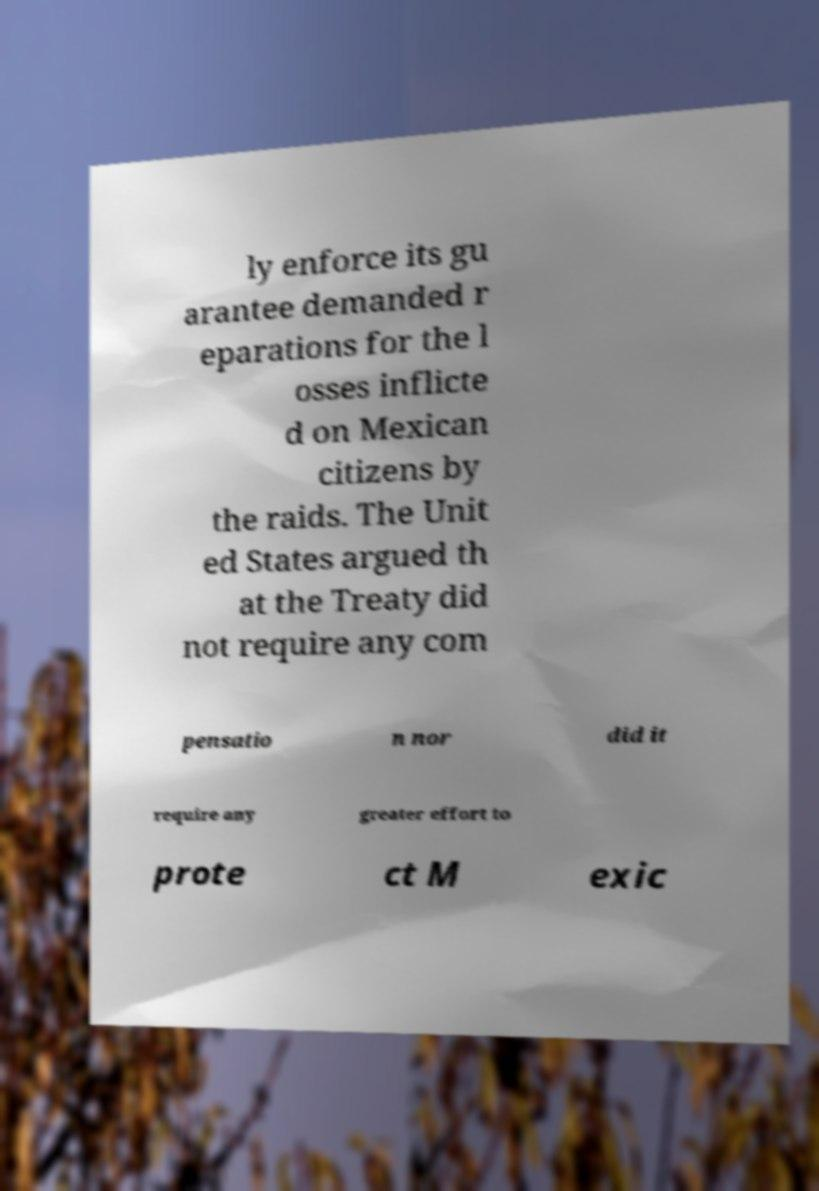Could you extract and type out the text from this image? ly enforce its gu arantee demanded r eparations for the l osses inflicte d on Mexican citizens by the raids. The Unit ed States argued th at the Treaty did not require any com pensatio n nor did it require any greater effort to prote ct M exic 